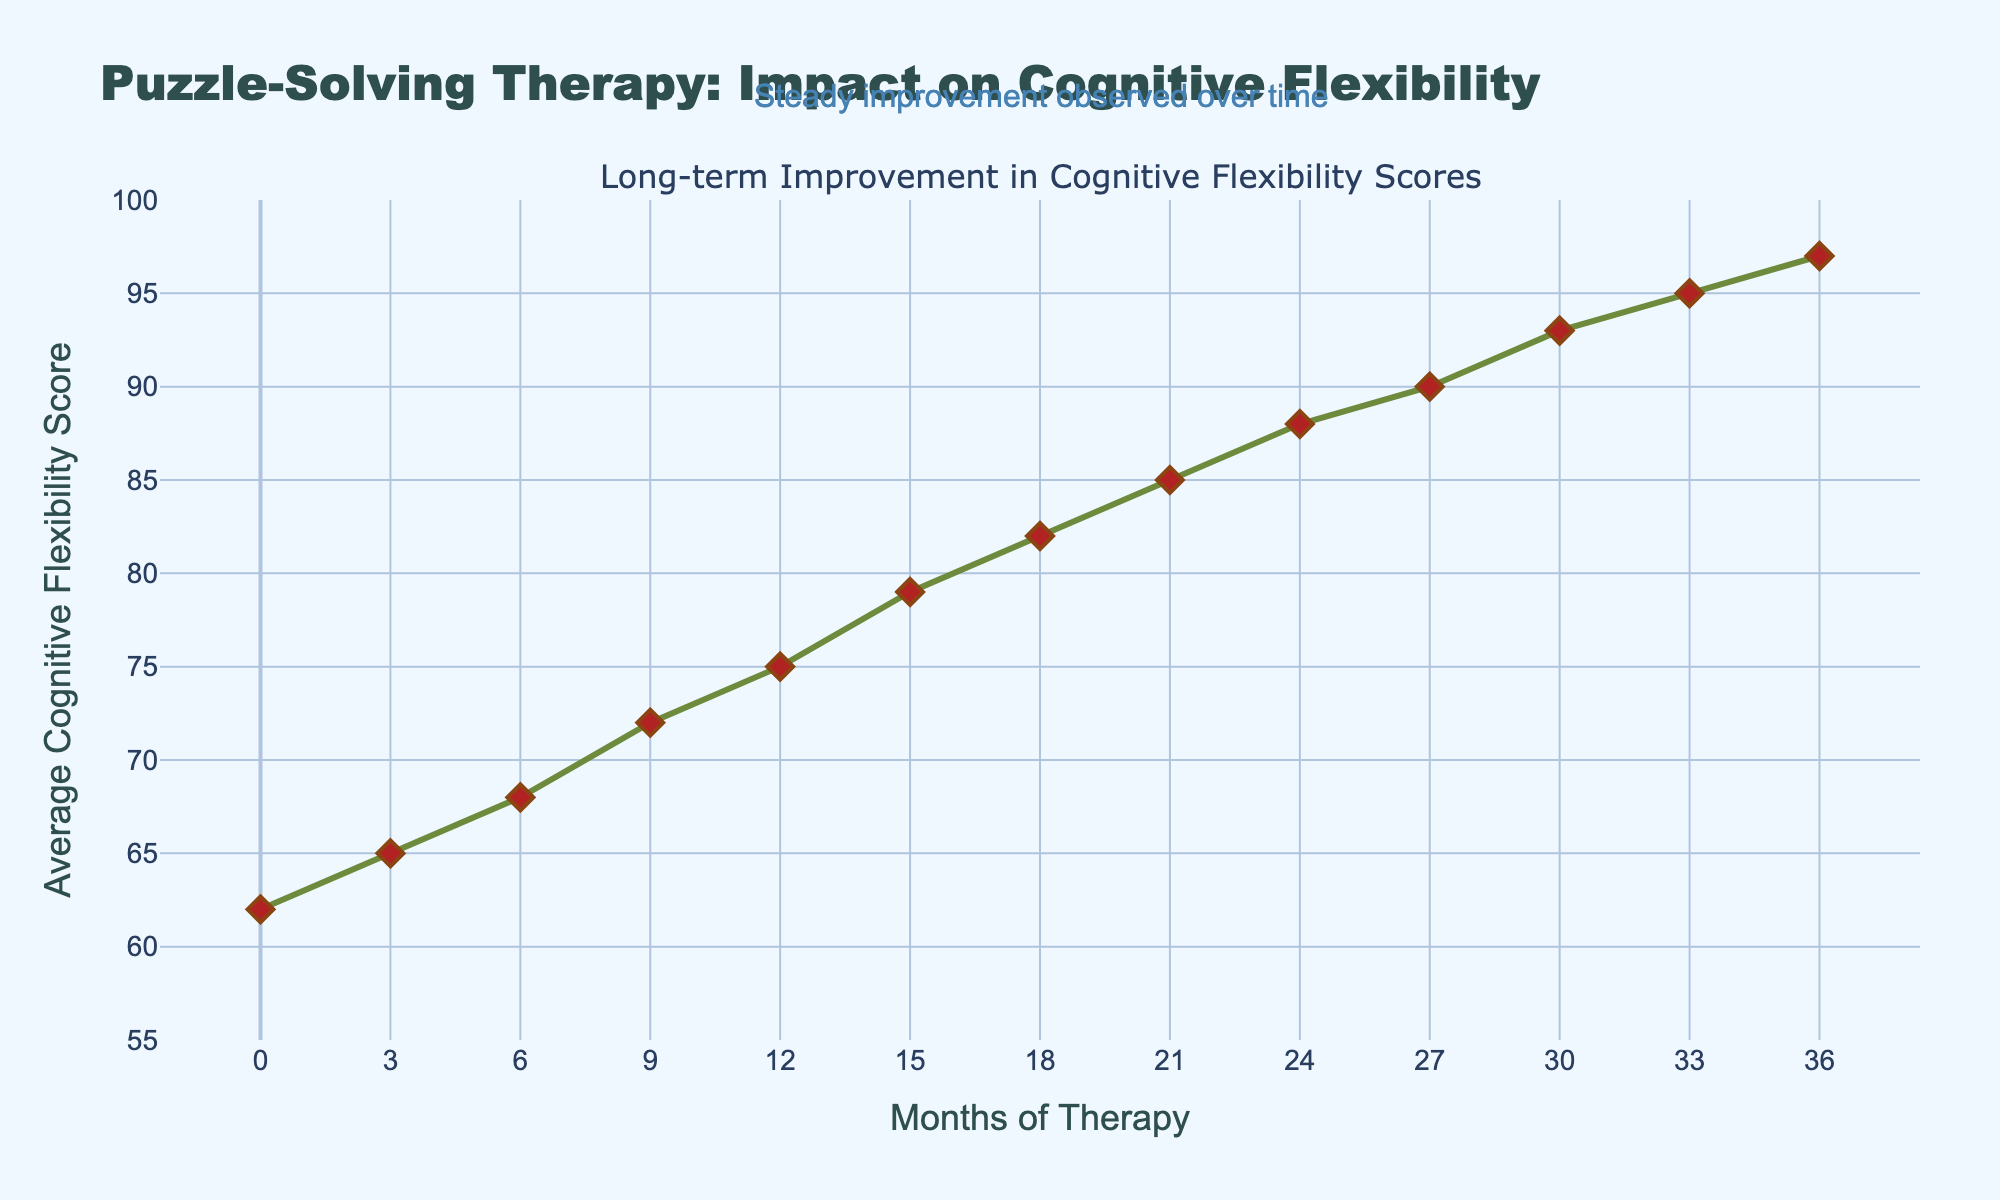What is the overall trend in the average cognitive flexibility score over the 36 months of therapy? The line in the chart depicting the average cognitive flexibility score shows a consistent upward trend from 62 to 97 over the 36 months. This indicates a steady improvement in scores over time.
Answer: Increasing How much did the average cognitive flexibility score increase from Month 0 to Month 36? At Month 0, the score is 62, and at Month 36, the score is 97. The increase is calculated by subtracting the initial score from the final score: 97 - 62 = 35.
Answer: 35 Between which two consecutive data points is the largest increase in the cognitive flexibility score observed? Reviewing the increments between consecutive points, the largest increase is seen between Month 0 to Month 3 (3 points), Month 3 to Month 6 (3 points), and so on, with a uniform increase pattern. The largest increment is distinctly observed between Month 12 (75) to Month 15 (79), where the score jumps by 4 points.
Answer: 12 to 15 What is the average cognitive flexibility score at the midpoint of the therapy (Month 18)? The chart shows the average cognitive flexibility score at Month 18 is 82.
Answer: 82 Is there a period where the increase in average cognitive flexibility score is particularly noteworthy? The period from Month 12 to Month 15 shows a noticeable 4-point increase (from 75 to 79), whereas other periods mostly show 3-point increases on average.
Answer: Yes, Month 12 to 15 What is the average of the cognitive flexibility scores at the start (Month 0), midpoint (Month 18), and end (Month 36) of therapy? At Month 0 the score is 62, at Month 18 it's 82, and at Month 36 it's 97. The average is calculated as (62 + 82 + 97) / 3 which equals 241 / 3 = 80.33.
Answer: 80.33 Is there any point where the increase from the previous score was less than 3 points? All increments between consecutive points are either 3 or more points; there is no period showing an increase less than 3 points.
Answer: No How does the score at Month 9 compare to the score at Month 24? At Month 9, the score is 72, and at Month 24, it's 88. Hence, the score at Month 24 is higher by 16 points compared to Month 9.
Answer: Higher by 16 points How does the visual aspect of the marks (e.g., shape, color) help convey information in the chart? The markers are diamond-shaped, colored red, and with a surrounding line, making them stand out against the green line. This helps in clearly identifying each data point.
Answer: Distinctive and clear What has been the general rate of increase per quarter (every 3 months) in terms of average cognitive flexibility score? Observing the data points, the scores rise approximately 3 points every 3 months, with slight variations, summarizing to a consistent general rate of increase.
Answer: Approximately 3 points per quarter 